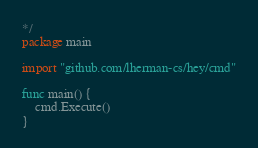Convert code to text. <code><loc_0><loc_0><loc_500><loc_500><_Go_>*/
package main

import "github.com/lherman-cs/hey/cmd"

func main() {
	cmd.Execute()
}
</code> 